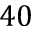Convert formula to latex. <formula><loc_0><loc_0><loc_500><loc_500>4 0</formula> 